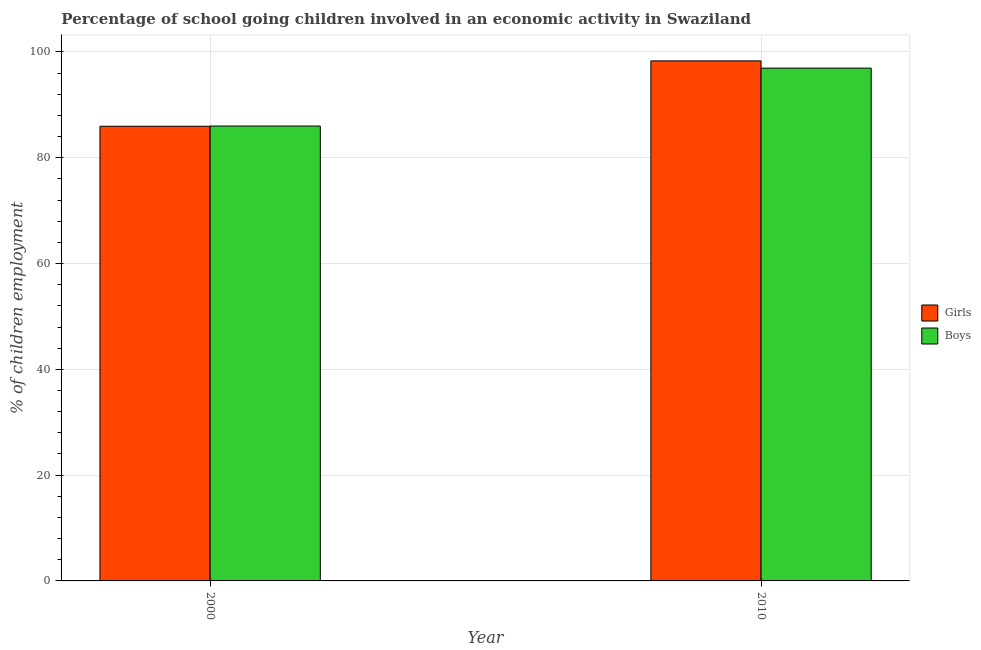How many groups of bars are there?
Offer a very short reply. 2. How many bars are there on the 2nd tick from the left?
Offer a terse response. 2. How many bars are there on the 1st tick from the right?
Keep it short and to the point. 2. What is the label of the 1st group of bars from the left?
Offer a very short reply. 2000. In how many cases, is the number of bars for a given year not equal to the number of legend labels?
Your answer should be very brief. 0. What is the percentage of school going girls in 2000?
Your response must be concise. 85.96. Across all years, what is the maximum percentage of school going girls?
Make the answer very short. 98.32. Across all years, what is the minimum percentage of school going girls?
Your answer should be compact. 85.96. In which year was the percentage of school going boys minimum?
Give a very brief answer. 2000. What is the total percentage of school going girls in the graph?
Your answer should be very brief. 184.28. What is the difference between the percentage of school going boys in 2000 and that in 2010?
Your answer should be very brief. -10.95. What is the difference between the percentage of school going boys in 2010 and the percentage of school going girls in 2000?
Offer a very short reply. 10.95. What is the average percentage of school going girls per year?
Make the answer very short. 92.14. In how many years, is the percentage of school going boys greater than 4 %?
Your answer should be compact. 2. What is the ratio of the percentage of school going boys in 2000 to that in 2010?
Make the answer very short. 0.89. What does the 1st bar from the left in 2010 represents?
Make the answer very short. Girls. What does the 2nd bar from the right in 2010 represents?
Provide a short and direct response. Girls. Are all the bars in the graph horizontal?
Your answer should be very brief. No. How many years are there in the graph?
Keep it short and to the point. 2. Are the values on the major ticks of Y-axis written in scientific E-notation?
Give a very brief answer. No. Does the graph contain grids?
Keep it short and to the point. Yes. What is the title of the graph?
Your response must be concise. Percentage of school going children involved in an economic activity in Swaziland. What is the label or title of the X-axis?
Give a very brief answer. Year. What is the label or title of the Y-axis?
Your answer should be very brief. % of children employment. What is the % of children employment in Girls in 2000?
Give a very brief answer. 85.96. What is the % of children employment of Boys in 2000?
Provide a short and direct response. 86. What is the % of children employment of Girls in 2010?
Provide a succinct answer. 98.32. What is the % of children employment of Boys in 2010?
Your answer should be compact. 96.95. Across all years, what is the maximum % of children employment in Girls?
Make the answer very short. 98.32. Across all years, what is the maximum % of children employment of Boys?
Make the answer very short. 96.95. Across all years, what is the minimum % of children employment of Girls?
Your response must be concise. 85.96. Across all years, what is the minimum % of children employment of Boys?
Keep it short and to the point. 86. What is the total % of children employment of Girls in the graph?
Keep it short and to the point. 184.28. What is the total % of children employment of Boys in the graph?
Give a very brief answer. 182.95. What is the difference between the % of children employment of Girls in 2000 and that in 2010?
Your answer should be very brief. -12.36. What is the difference between the % of children employment in Boys in 2000 and that in 2010?
Provide a short and direct response. -10.95. What is the difference between the % of children employment in Girls in 2000 and the % of children employment in Boys in 2010?
Ensure brevity in your answer.  -10.99. What is the average % of children employment in Girls per year?
Offer a terse response. 92.14. What is the average % of children employment of Boys per year?
Your answer should be compact. 91.47. In the year 2000, what is the difference between the % of children employment of Girls and % of children employment of Boys?
Your response must be concise. -0.04. In the year 2010, what is the difference between the % of children employment in Girls and % of children employment in Boys?
Your response must be concise. 1.37. What is the ratio of the % of children employment of Girls in 2000 to that in 2010?
Keep it short and to the point. 0.87. What is the ratio of the % of children employment of Boys in 2000 to that in 2010?
Keep it short and to the point. 0.89. What is the difference between the highest and the second highest % of children employment in Girls?
Give a very brief answer. 12.36. What is the difference between the highest and the second highest % of children employment of Boys?
Your answer should be very brief. 10.95. What is the difference between the highest and the lowest % of children employment in Girls?
Offer a very short reply. 12.36. What is the difference between the highest and the lowest % of children employment in Boys?
Ensure brevity in your answer.  10.95. 